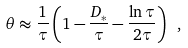Convert formula to latex. <formula><loc_0><loc_0><loc_500><loc_500>\theta \approx \frac { 1 } { \tau } \left ( 1 - \frac { D _ { * } } { \tau } - \frac { \ln \tau } { 2 \tau } \right ) \ ,</formula> 